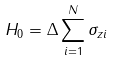Convert formula to latex. <formula><loc_0><loc_0><loc_500><loc_500>H _ { 0 } = \Delta \sum _ { i = 1 } ^ { N } \sigma _ { z i }</formula> 